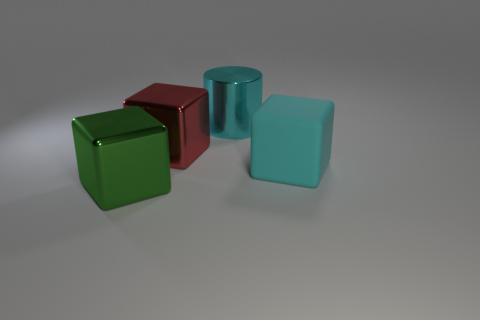Can you tell me about the lighting in this image? The lighting in the image creates soft shadows on the surface beneath the objects. It seems to come from above, providing even illumination that highlights the shapes and textures of the objects without creating harsh contrasts. 